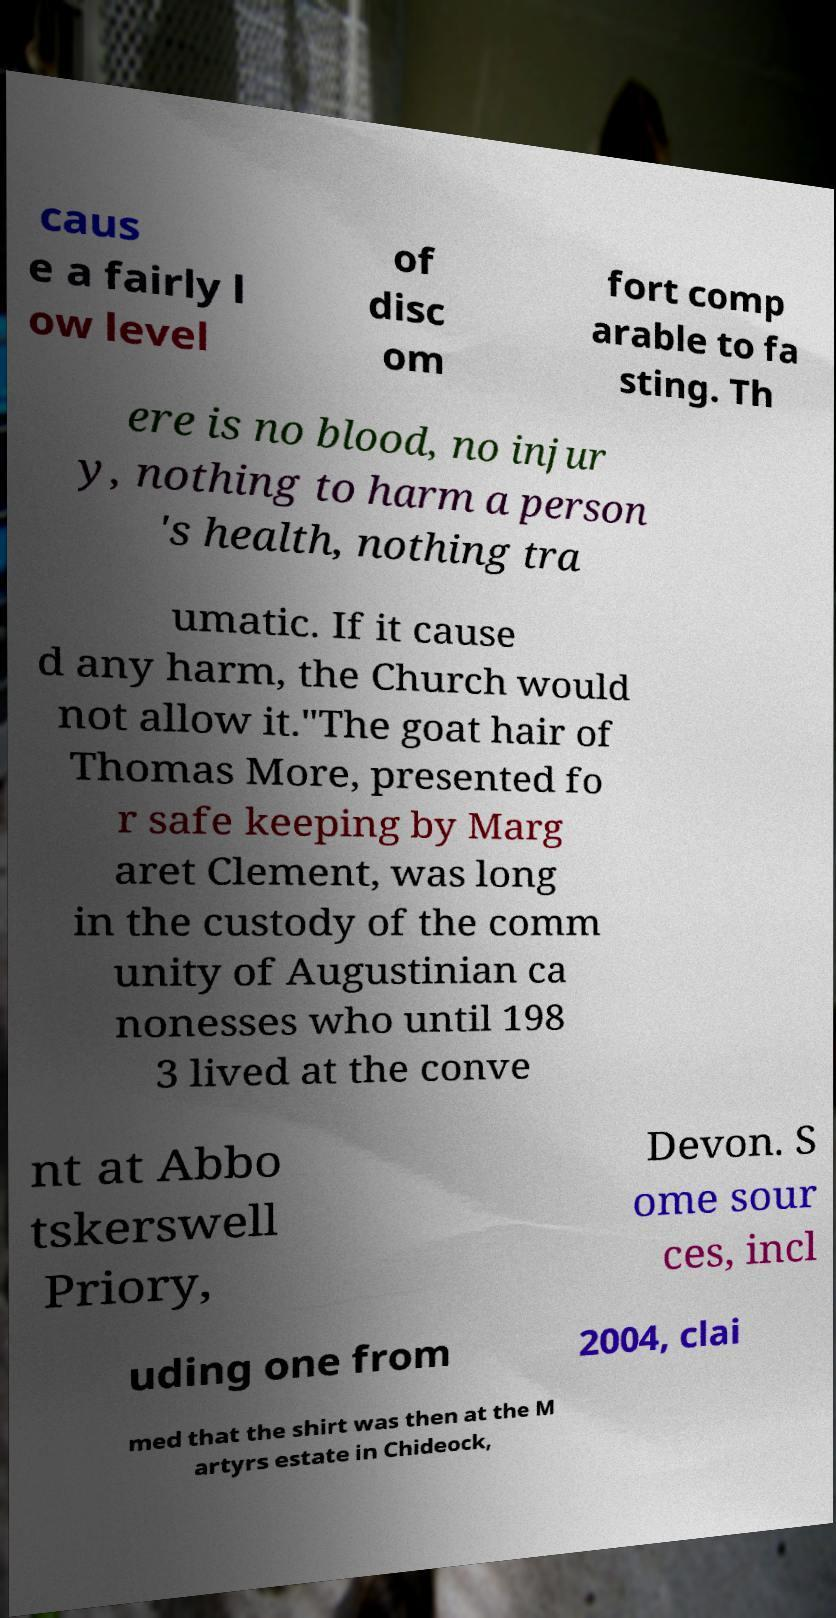There's text embedded in this image that I need extracted. Can you transcribe it verbatim? caus e a fairly l ow level of disc om fort comp arable to fa sting. Th ere is no blood, no injur y, nothing to harm a person 's health, nothing tra umatic. If it cause d any harm, the Church would not allow it."The goat hair of Thomas More, presented fo r safe keeping by Marg aret Clement, was long in the custody of the comm unity of Augustinian ca nonesses who until 198 3 lived at the conve nt at Abbo tskerswell Priory, Devon. S ome sour ces, incl uding one from 2004, clai med that the shirt was then at the M artyrs estate in Chideock, 